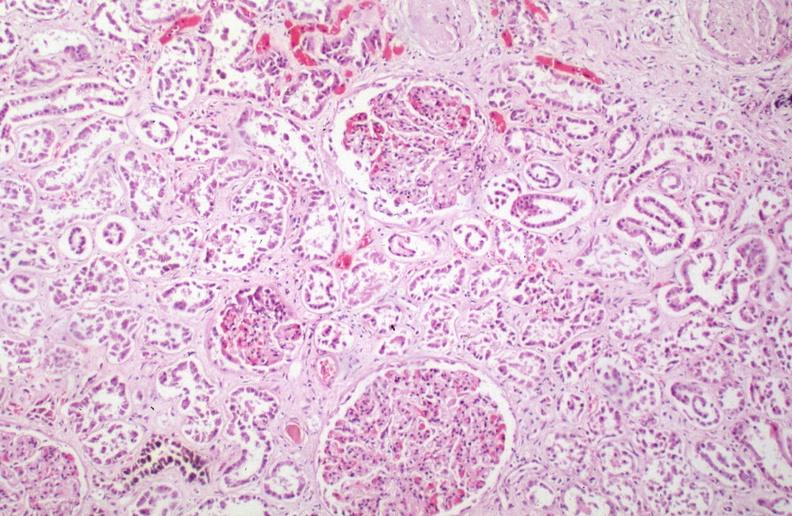does one show kidney, chronic sickle cell disease?
Answer the question using a single word or phrase. No 